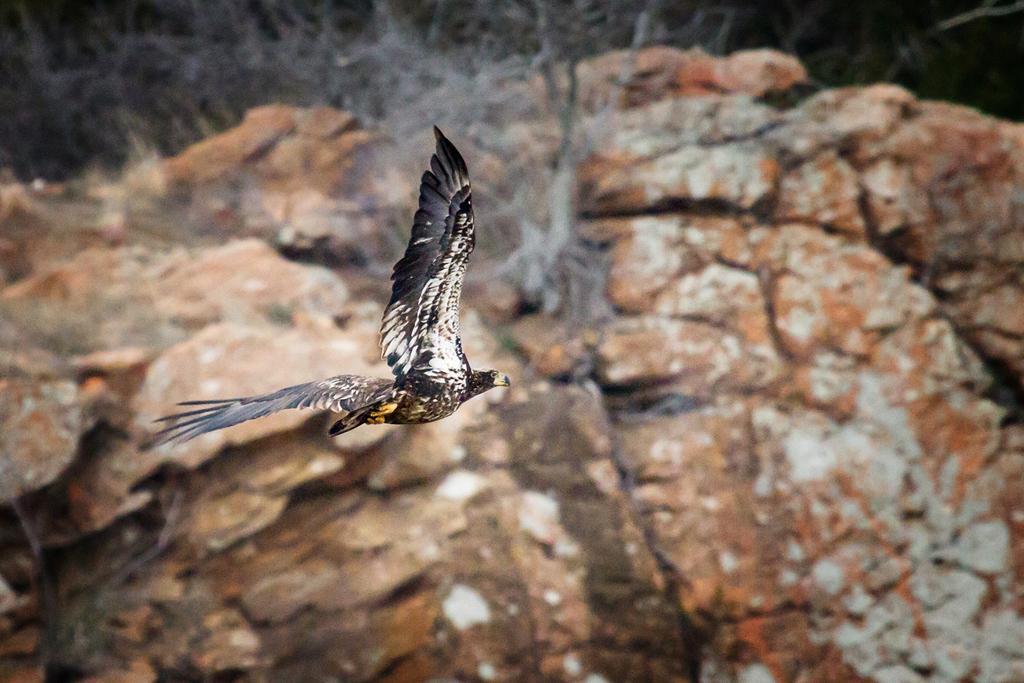Could you give a brief overview of what you see in this image? In the picture I can see a bird is flying in the air. In the background I can see rocks and some other things. The background of the image is blurred. 